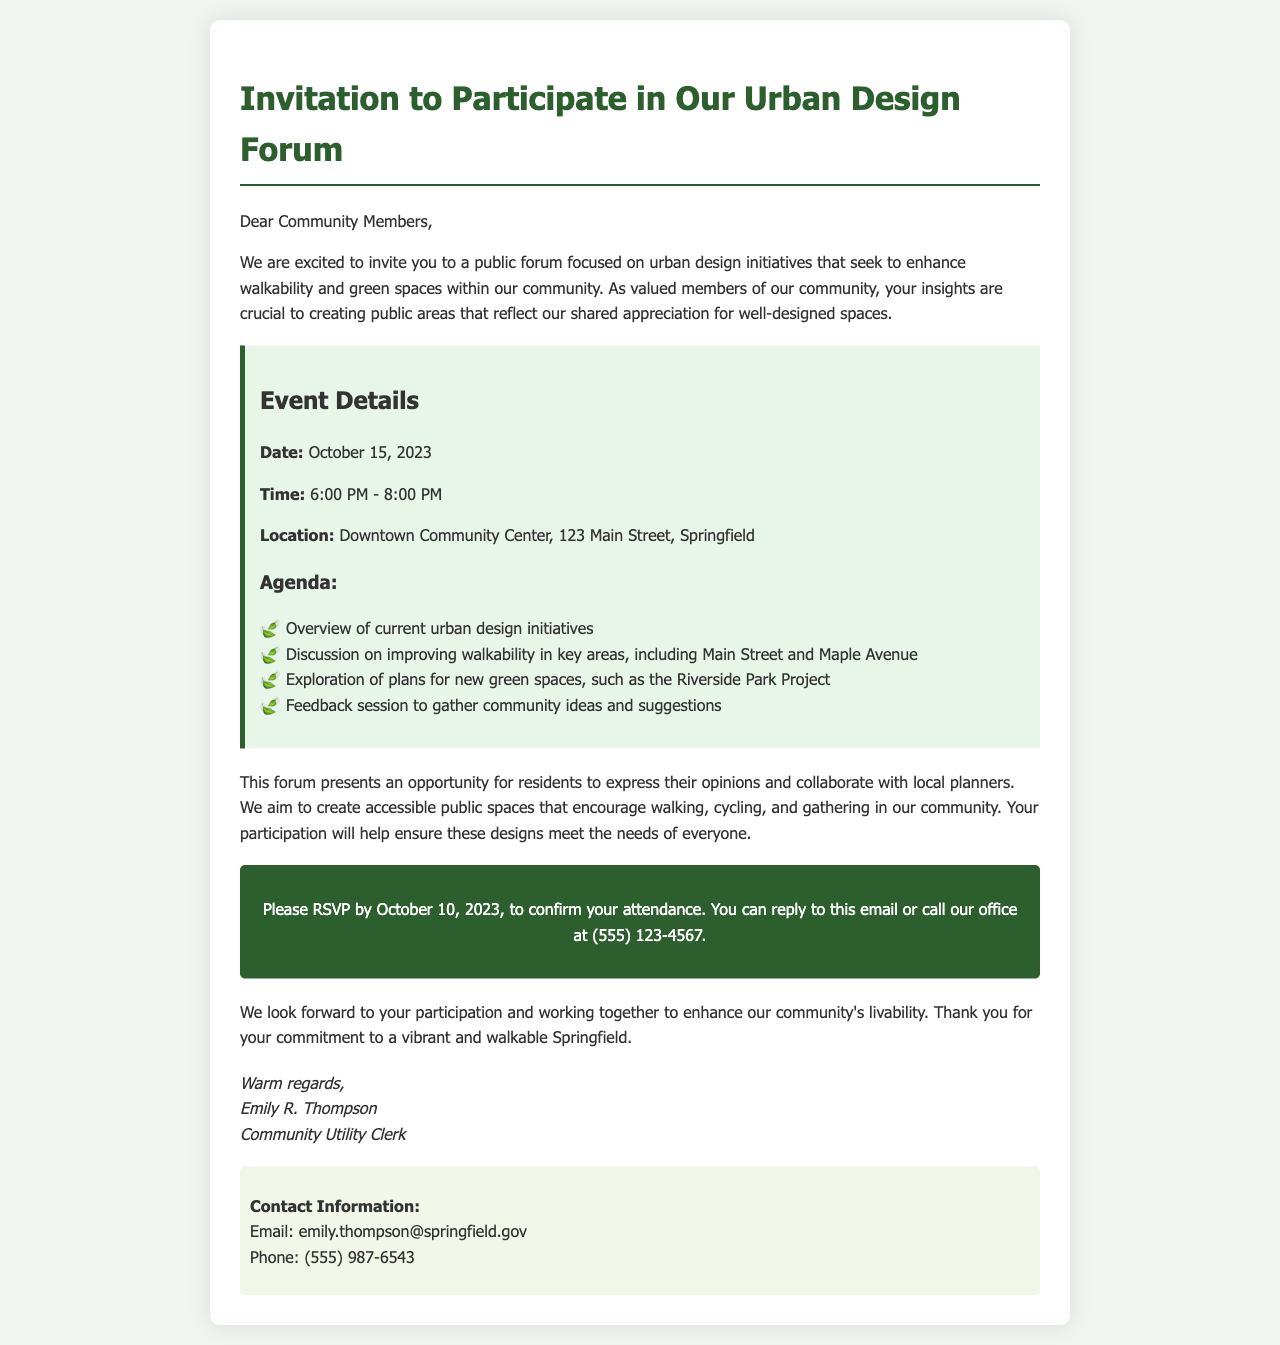What is the date of the forum? The date of the forum is mentioned directly in the event details section of the document.
Answer: October 15, 2023 What time does the forum start? The start time of the forum is specified in the event details section.
Answer: 6:00 PM Where is the forum taking place? The location of the forum is provided in the event details.
Answer: Downtown Community Center, 123 Main Street, Springfield What is one of the agenda items? The agenda lists several discussion points, and one example can be "Overview of current urban design initiatives."
Answer: Overview of current urban design initiatives How can a resident confirm their attendance? The method for confirming attendance is outlined in the call-to-action section.
Answer: Reply to this email or call our office What does the forum aim to enhance? The primary focus of the forum is stated within the introductory paragraph regarding urban design initiatives.
Answer: Walkability and green spaces What is the deadline for RSVPs? The deadline for RSVPs is specifically mentioned in the call-to-action section of the document.
Answer: October 10, 2023 Who is the sender of the invitation? The signature at the end of the document provides the name and title of the sender.
Answer: Emily R. Thompson What is included in the contact information section? The contact information section includes methods for reaching the sender, such as email and phone.
Answer: Email: emily.thompson@springfield.gov; Phone: (555) 987-6543 